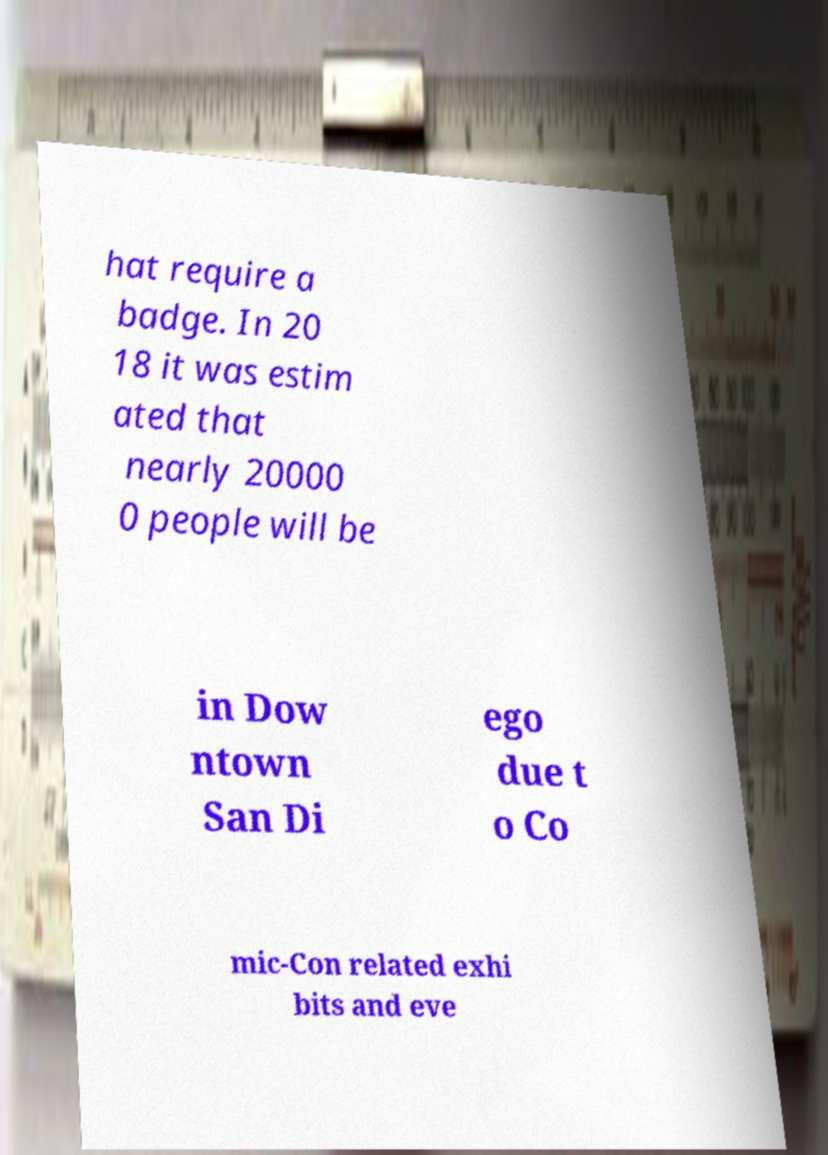What messages or text are displayed in this image? I need them in a readable, typed format. hat require a badge. In 20 18 it was estim ated that nearly 20000 0 people will be in Dow ntown San Di ego due t o Co mic-Con related exhi bits and eve 